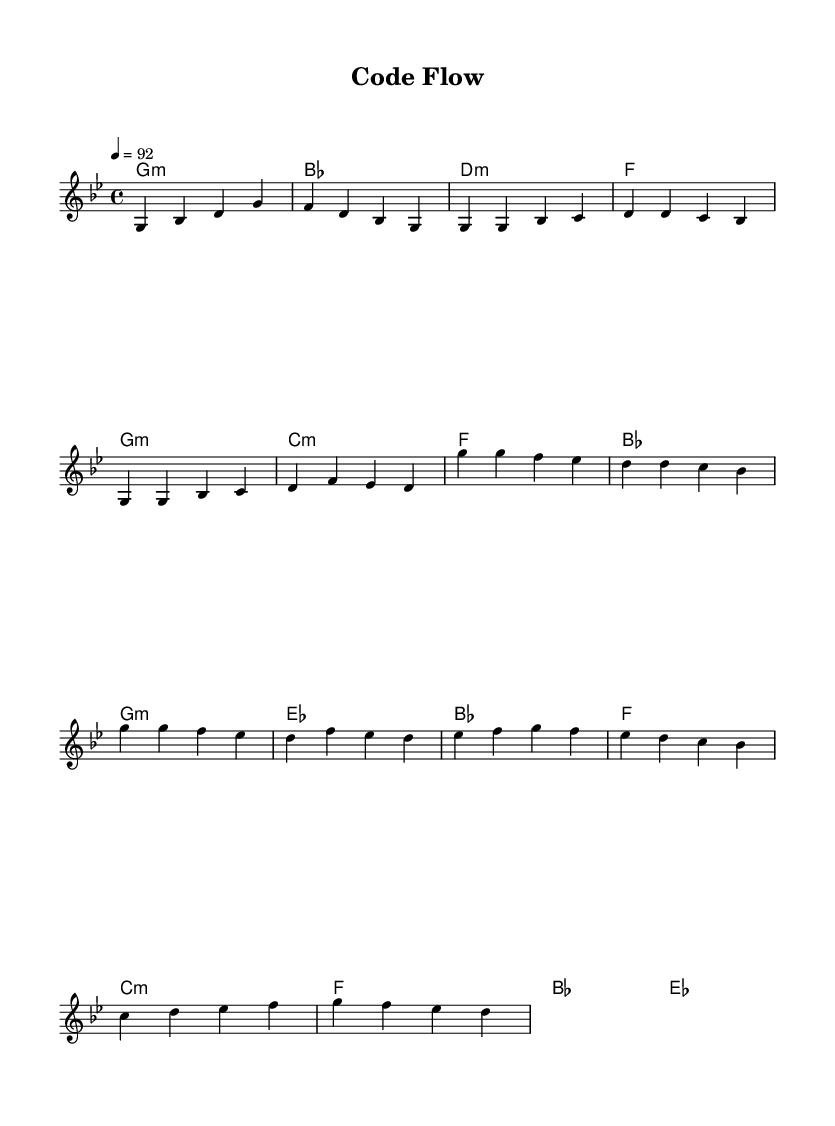What is the key signature of this music? The key signature is G minor, which has two flats (B♭ and E♭). This can be identified by looking at the beginning of the staff where the key signature is notated.
Answer: G minor What is the time signature of this music? The time signature is 4/4, which is indicated at the beginning of the score. This means there are four beats in each measure and the quarter note gets one beat.
Answer: 4/4 What is the tempo marking of this piece? The tempo marking is quarter note equals 92. This is found in the tempo indication at the beginning of the music, which dictates the speed of the piece.
Answer: 92 How many measures are in the verse section? The verse section consists of two lines of music. Each line has four measures, leading to a total of eight measures for the verse.
Answer: 8 Which chord follows the C minor chord in the verse? The chord that follows the C minor chord in the verse is the F chord. This can be determined by examining the chord changes in the harmonies section of the verse music.
Answer: F How does the melody of the chorus differ from the verse? The melody of the chorus starts on G and has a different melodic contour compared to the verse, which starts on G but varies in pitch and rhythm. The chorus also contains the same notes, but they are arranged differently to create a distinct sound.
Answer: Different melody What thematic element does the bridge introduce? The bridge introduces a contrast with a different musical texture and explores key elements of development and innovation, often deviating from the established patterns in the verse and chorus. This adds dynamic variety to the piece.
Answer: Contrast 